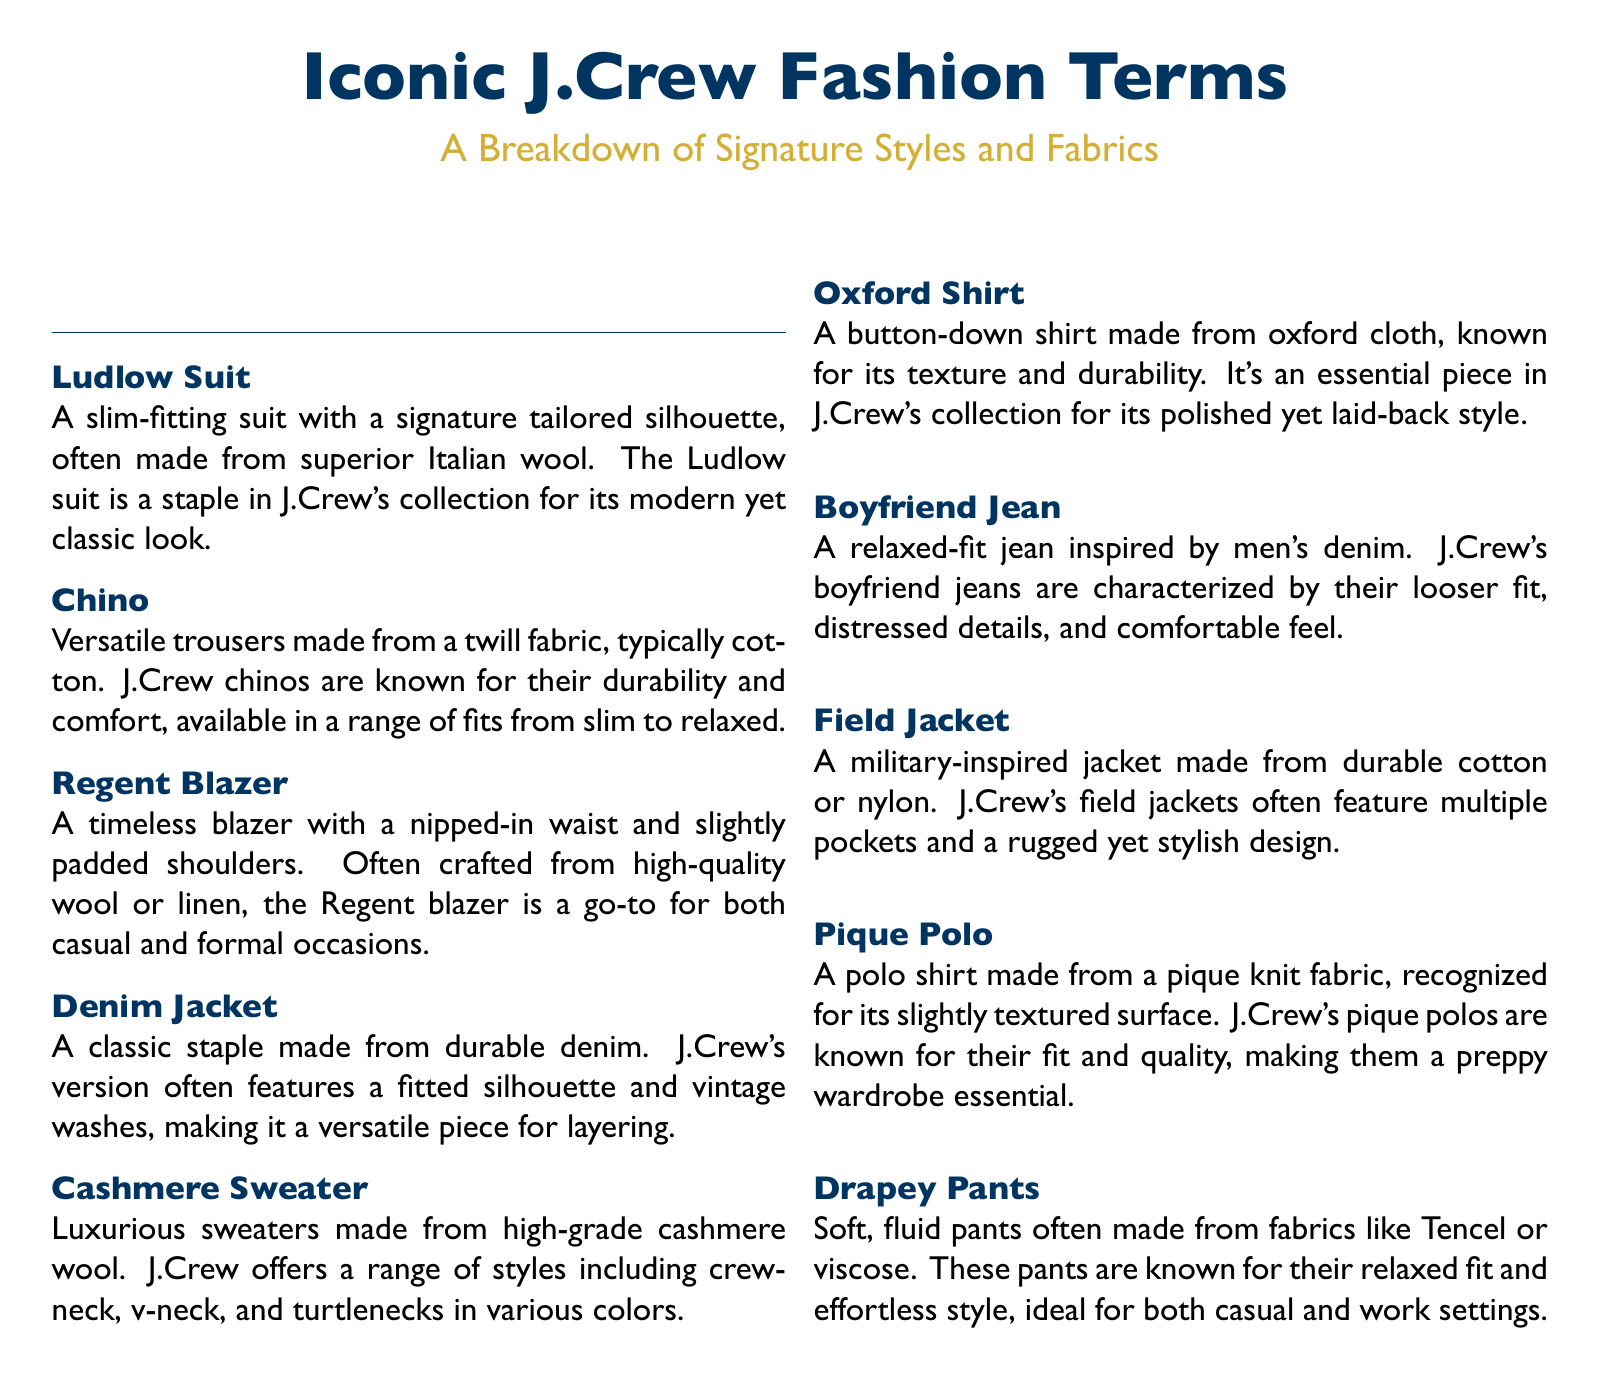what is a Ludlow Suit? The Ludlow Suit is described as a slim-fitting suit with a signature tailored silhouette, often made from superior Italian wool.
Answer: A slim-fitting suit what fabric are J.Crew chinos typically made from? J.Crew chinos are typically made from twill fabric, usually cotton.
Answer: Cotton what is a defining feature of the Regent Blazer? The Regent Blazer is characterized by a nipped-in waist and slightly padded shoulders.
Answer: Nipped-in waist what type of jeans are Boyfriend Jeans inspired by? Boyfriend Jeans are inspired by men's denim, featuring a relaxed fit.
Answer: Men's denim what is the texture of an Oxford Shirt made from? The Oxford Shirt is made from oxford cloth, which is known for its texture and durability.
Answer: Oxford cloth what is a common style of J.Crew cashmere sweater? J.Crew offers a range of styles for cashmere sweaters including crewneck, v-neck, and turtlenecks.
Answer: Crewneck how are J.Crew pique polos described? J.Crew's pique polos are known for their fit and quality, often recognized by their slightly textured surface.
Answer: Fit and quality what material are Drapey Pants commonly made from? Drapey Pants are often made from fabrics like Tencel or viscose.
Answer: Tencel or viscose what is the purpose of J.Crew's Field Jacket? The Field Jacket is designed to be military-inspired with multiple pockets and a rugged yet stylish design.
Answer: Military-inspired design 